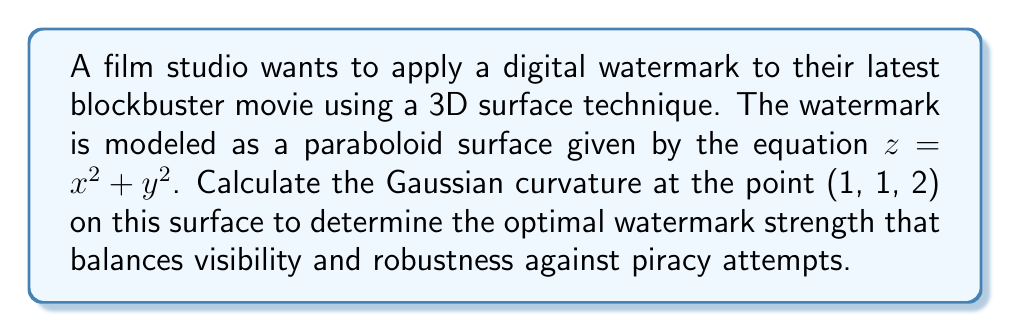Help me with this question. To calculate the Gaussian curvature of the surface $z = x^2 + y^2$ at the point (1, 1, 2), we'll follow these steps:

1) First, we need to find the partial derivatives:
   $f_x = 2x$, $f_y = 2y$, $f_{xx} = 2$, $f_{yy} = 2$, $f_{xy} = 0$

2) At the point (1, 1, 2), these values are:
   $f_x = 2$, $f_y = 2$, $f_{xx} = 2$, $f_{yy} = 2$, $f_{xy} = 0$

3) The Gaussian curvature K is given by the formula:

   $$K = \frac{f_{xx}f_{yy} - f_{xy}^2}{(1 + f_x^2 + f_y^2)^2}$$

4) Substituting our values:

   $$K = \frac{(2)(2) - (0)^2}{(1 + 2^2 + 2^2)^2}$$

5) Simplify:
   $$K = \frac{4}{(1 + 4 + 4)^2} = \frac{4}{9^2} = \frac{4}{81}$$

Therefore, the Gaussian curvature at the point (1, 1, 2) is $\frac{4}{81}$.
Answer: $\frac{4}{81}$ 